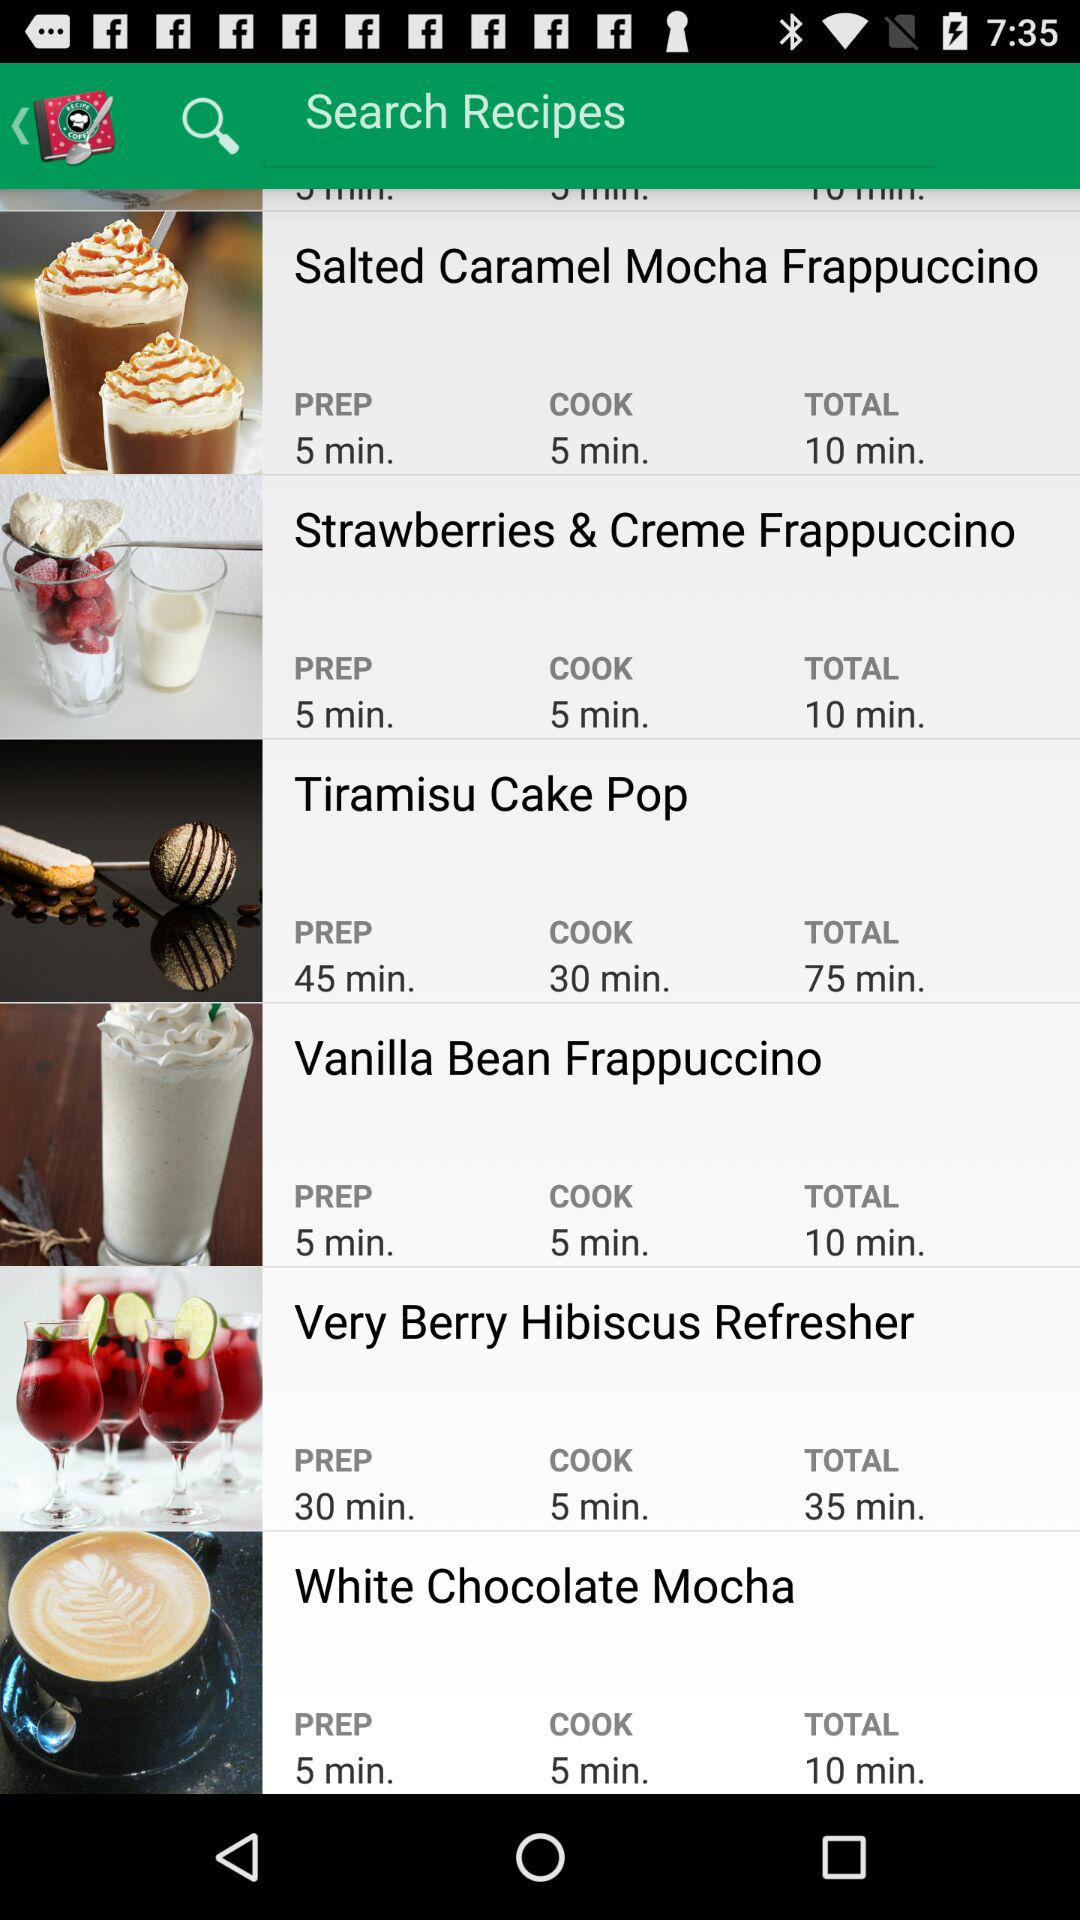How long does it take to make a "Vanilla Bean Frappuccino"? It takes 10 minutes to make a "Vanilla Bean Frappuccino". 